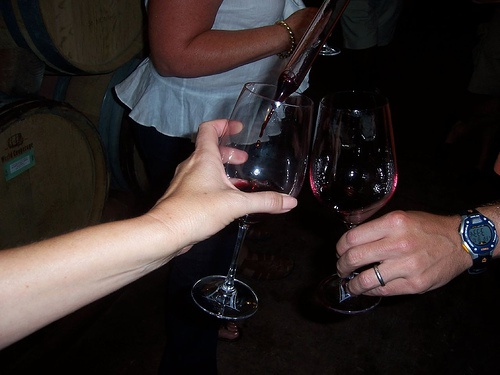Describe the objects in this image and their specific colors. I can see people in black, tan, lightgray, and darkgray tones, people in black, maroon, and gray tones, people in black, brown, and salmon tones, wine glass in black, gray, and darkblue tones, and wine glass in black, maroon, and gray tones in this image. 